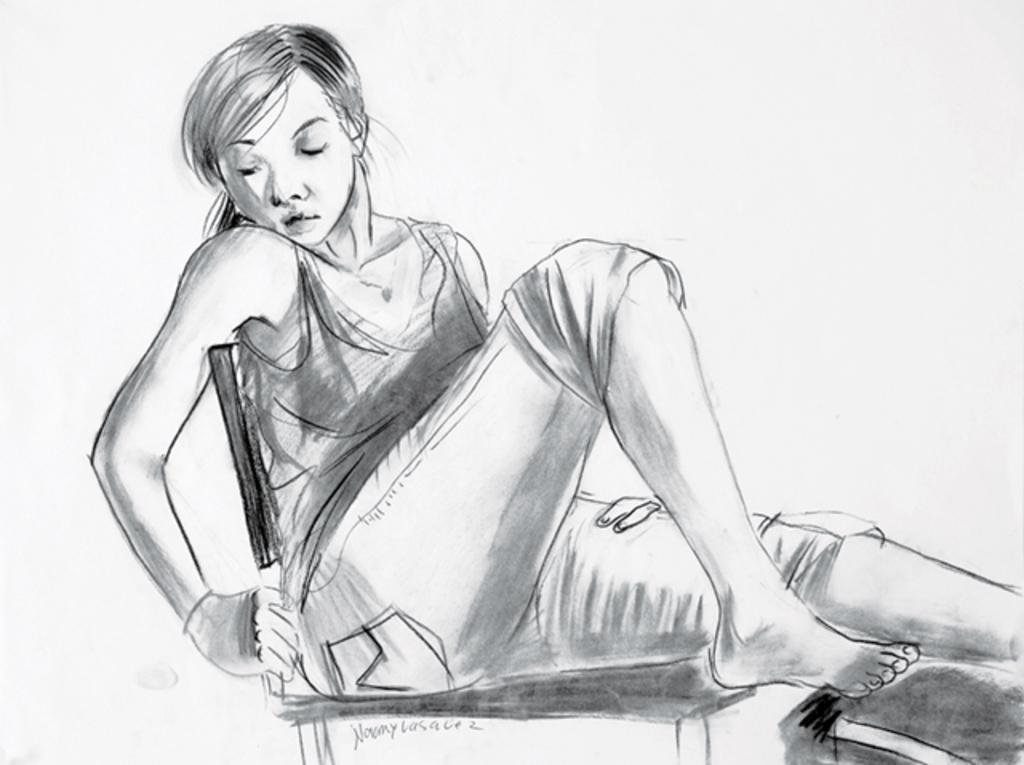What is depicted in the image? There is a sketch of a lady in the image. What is the lady doing in the sketch? The lady is sitting on a chair in the sketch. What can be found at the bottom of the image? There is text at the bottom of the image. What color is the background of the image? The background of the image is white. What type of bread is being used as a territory marker in the image? There is no bread or territory marker present in the image. What kind of leaf is visible on the lady's chair in the image? There is no leaf visible on the lady's chair in the image. 